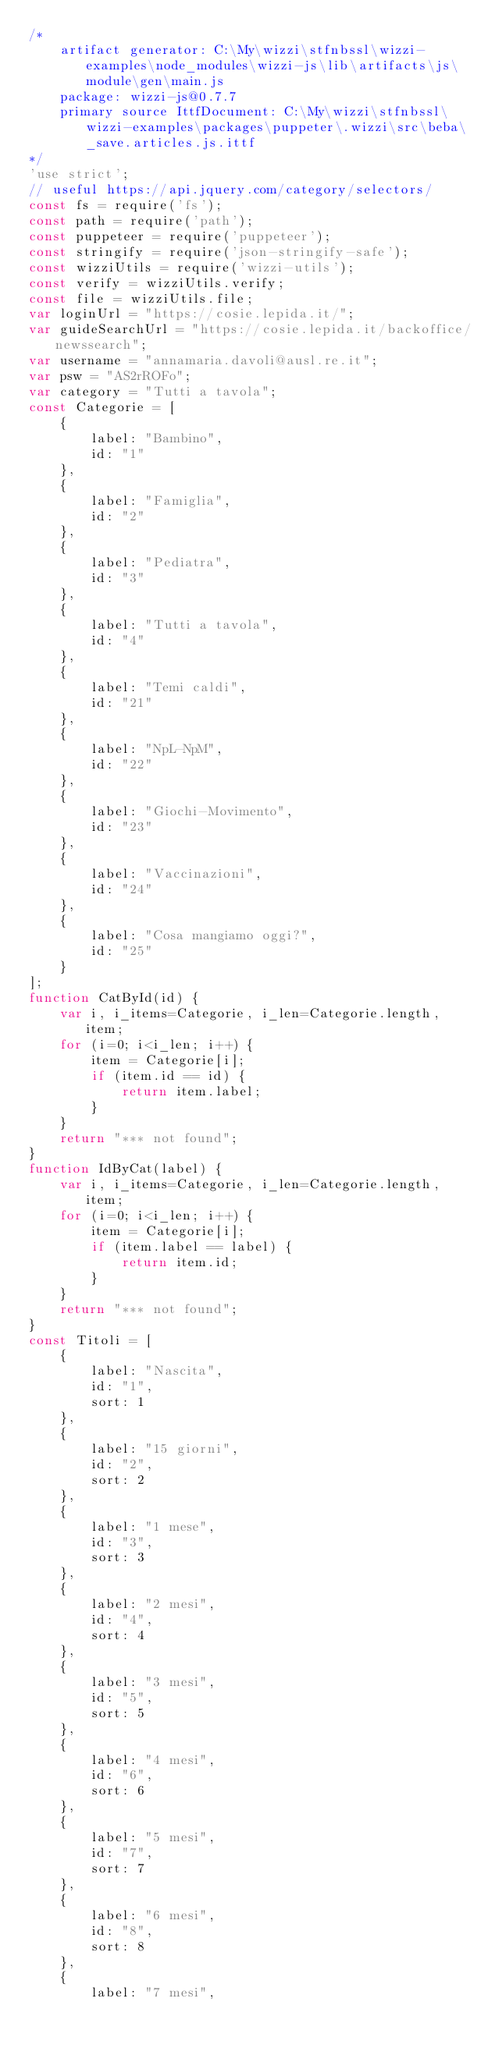Convert code to text. <code><loc_0><loc_0><loc_500><loc_500><_JavaScript_>/*
    artifact generator: C:\My\wizzi\stfnbssl\wizzi-examples\node_modules\wizzi-js\lib\artifacts\js\module\gen\main.js
    package: wizzi-js@0.7.7
    primary source IttfDocument: C:\My\wizzi\stfnbssl\wizzi-examples\packages\puppeter\.wizzi\src\beba\_save.articles.js.ittf
*/
'use strict';
// useful https://api.jquery.com/category/selectors/
const fs = require('fs');
const path = require('path');
const puppeteer = require('puppeteer');
const stringify = require('json-stringify-safe');
const wizziUtils = require('wizzi-utils');
const verify = wizziUtils.verify;
const file = wizziUtils.file;
var loginUrl = "https://cosie.lepida.it/";
var guideSearchUrl = "https://cosie.lepida.it/backoffice/newssearch";
var username = "annamaria.davoli@ausl.re.it";
var psw = "AS2rROFo";
var category = "Tutti a tavola";
const Categorie = [
    {
        label: "Bambino", 
        id: "1"
    }, 
    {
        label: "Famiglia", 
        id: "2"
    }, 
    {
        label: "Pediatra", 
        id: "3"
    }, 
    {
        label: "Tutti a tavola", 
        id: "4"
    }, 
    {
        label: "Temi caldi", 
        id: "21"
    }, 
    {
        label: "NpL-NpM", 
        id: "22"
    }, 
    {
        label: "Giochi-Movimento", 
        id: "23"
    }, 
    {
        label: "Vaccinazioni", 
        id: "24"
    }, 
    {
        label: "Cosa mangiamo oggi?", 
        id: "25"
    }
];
function CatById(id) {
    var i, i_items=Categorie, i_len=Categorie.length, item;
    for (i=0; i<i_len; i++) {
        item = Categorie[i];
        if (item.id == id) {
            return item.label;
        }
    }
    return "*** not found";
}
function IdByCat(label) {
    var i, i_items=Categorie, i_len=Categorie.length, item;
    for (i=0; i<i_len; i++) {
        item = Categorie[i];
        if (item.label == label) {
            return item.id;
        }
    }
    return "*** not found";
}
const Titoli = [
    {
        label: "Nascita", 
        id: "1", 
        sort: 1
    }, 
    {
        label: "15 giorni", 
        id: "2", 
        sort: 2
    }, 
    {
        label: "1 mese", 
        id: "3", 
        sort: 3
    }, 
    {
        label: "2 mesi", 
        id: "4", 
        sort: 4
    }, 
    {
        label: "3 mesi", 
        id: "5", 
        sort: 5
    }, 
    {
        label: "4 mesi", 
        id: "6", 
        sort: 6
    }, 
    {
        label: "5 mesi", 
        id: "7", 
        sort: 7
    }, 
    {
        label: "6 mesi", 
        id: "8", 
        sort: 8
    }, 
    {
        label: "7 mesi", </code> 